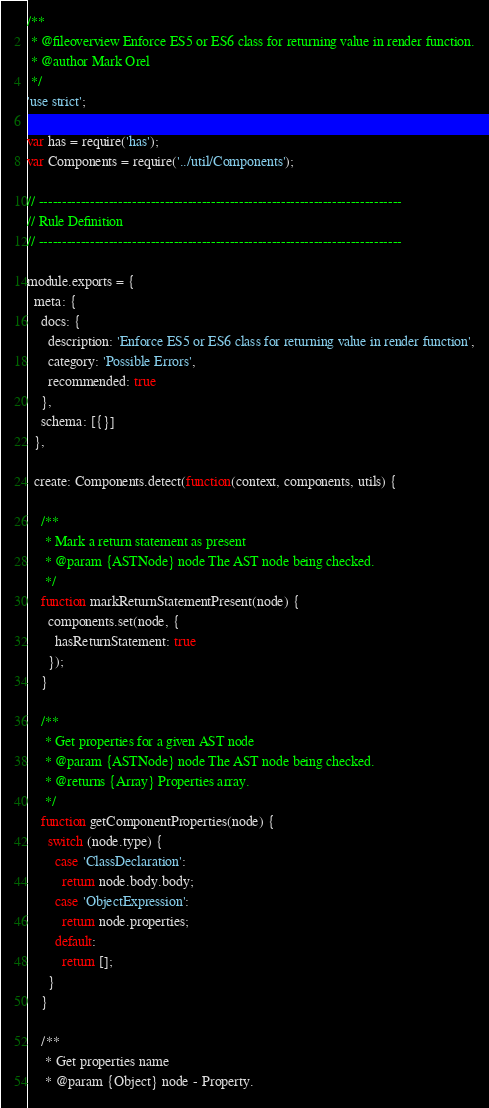<code> <loc_0><loc_0><loc_500><loc_500><_JavaScript_>/**
 * @fileoverview Enforce ES5 or ES6 class for returning value in render function.
 * @author Mark Orel
 */
'use strict';

var has = require('has');
var Components = require('../util/Components');

// ------------------------------------------------------------------------------
// Rule Definition
// ------------------------------------------------------------------------------

module.exports = {
  meta: {
    docs: {
      description: 'Enforce ES5 or ES6 class for returning value in render function',
      category: 'Possible Errors',
      recommended: true
    },
    schema: [{}]
  },

  create: Components.detect(function(context, components, utils) {

    /**
     * Mark a return statement as present
     * @param {ASTNode} node The AST node being checked.
     */
    function markReturnStatementPresent(node) {
      components.set(node, {
        hasReturnStatement: true
      });
    }

    /**
     * Get properties for a given AST node
     * @param {ASTNode} node The AST node being checked.
     * @returns {Array} Properties array.
     */
    function getComponentProperties(node) {
      switch (node.type) {
        case 'ClassDeclaration':
          return node.body.body;
        case 'ObjectExpression':
          return node.properties;
        default:
          return [];
      }
    }

    /**
     * Get properties name
     * @param {Object} node - Property.</code> 